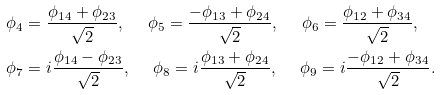<formula> <loc_0><loc_0><loc_500><loc_500>\phi _ { 4 } & = \frac { \phi _ { 1 4 } + \phi _ { 2 3 } } { \sqrt { 2 } } , \quad \ \phi _ { 5 } = \frac { - \phi _ { 1 3 } + \phi _ { 2 4 } } { \sqrt { 2 } } , \quad \ \phi _ { 6 } = \frac { \phi _ { 1 2 } + \phi _ { 3 4 } } { \sqrt { 2 } } , \\ \phi _ { 7 } & = i \frac { \phi _ { 1 4 } - \phi _ { 2 3 } } { \sqrt { 2 } } , \quad \ \phi _ { 8 } = i \frac { \phi _ { 1 3 } + \phi _ { 2 4 } } { \sqrt { 2 } } , \quad \ \phi _ { 9 } = i \frac { - \phi _ { 1 2 } + \phi _ { 3 4 } } { \sqrt { 2 } } .</formula> 